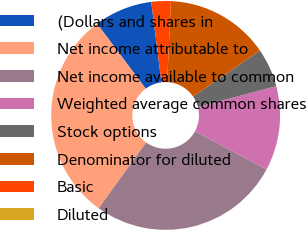Convert chart. <chart><loc_0><loc_0><loc_500><loc_500><pie_chart><fcel>(Dollars and shares in<fcel>Net income attributable to<fcel>Net income available to common<fcel>Weighted average common shares<fcel>Stock options<fcel>Denominator for diluted<fcel>Basic<fcel>Diluted<nl><fcel>8.21%<fcel>29.84%<fcel>27.11%<fcel>11.95%<fcel>5.47%<fcel>14.68%<fcel>2.74%<fcel>0.0%<nl></chart> 